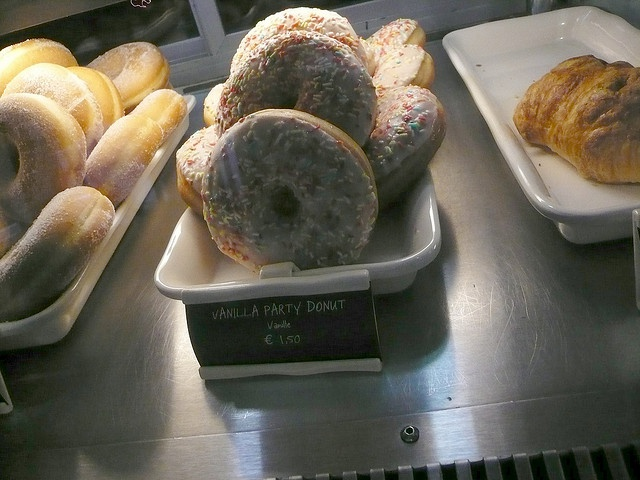Describe the objects in this image and their specific colors. I can see donut in black and gray tones, donut in black and gray tones, donut in black, beige, khaki, and maroon tones, donut in black, gray, and tan tones, and donut in black, gray, and tan tones in this image. 